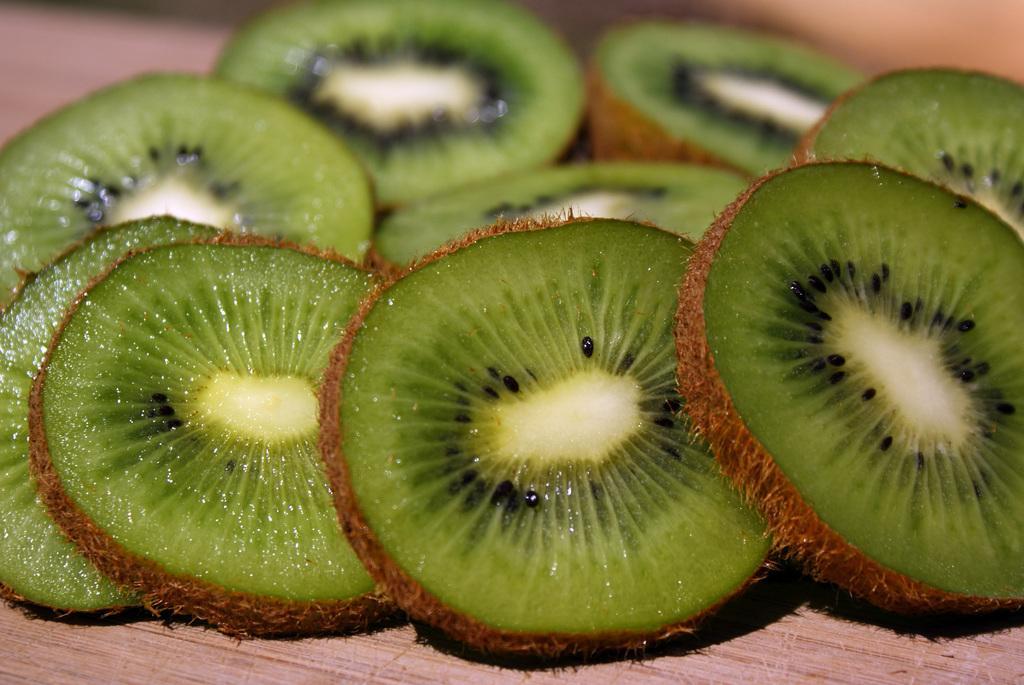How would you summarize this image in a sentence or two? In this image we can see chopped pieces of chico. 